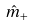<formula> <loc_0><loc_0><loc_500><loc_500>\hat { m } _ { + }</formula> 